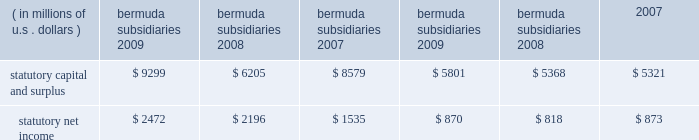N o t e s t o t h e c o n s o l i d a t e d f i n a n c i a l s t a t e m e n t s ( continued ) ace limited and subsidiaries 20 .
Statutory financial information the company 2019s insurance and reinsurance subsidiaries are subject to insurance laws and regulations in the jurisdictions in which they operate .
These regulations include restrictions that limit the amount of dividends or other distributions , such as loans or cash advances , available to shareholders without prior approval of the insurance regulatory authorities .
There are no statutory restrictions on the payment of dividends from retained earnings by any of the bermuda subsidiaries as the minimum statutory capital and surplus requirements are satisfied by the share capital and additional paid-in capital of each of the bermuda subsidiaries .
The company 2019s u.s .
Subsidiaries file financial statements prepared in accordance with statutory accounting practices prescribed or permitted by insurance regulators .
Statutory accounting differs from gaap in the reporting of certain reinsurance contracts , investments , subsidiaries , acquis- ition expenses , fixed assets , deferred income taxes , and certain other items .
The statutory capital and surplus of the u.s .
Subsidiaries met regulatory requirements for 2009 , 2008 , and 2007 .
The amount of dividends available to be paid in 2010 , without prior approval from the state insurance departments , totals $ 733 million .
The combined statutory capital and surplus and statutory net income of the bermuda and u.s .
Subsidiaries as at and for the years ended december 31 , 2009 , 2008 , and 2007 , are as follows: .
As permitted by the restructuring discussed previously in note 7 , certain of the company 2019s u.s .
Subsidiaries discount certain a&e liabilities , which increased statutory capital and surplus by approximately $ 215 million , $ 211 million , and $ 140 million at december 31 , 2009 , 2008 , and 2007 , respectively .
The company 2019s international subsidiaries prepare statutory financial statements based on local laws and regulations .
Some jurisdictions impose complex regulatory requirements on insurance companies while other jurisdictions impose fewer requirements .
In some countries , the company must obtain licenses issued by governmental authorities to conduct local insurance business .
These licenses may be subject to reserves and minimum capital and solvency tests .
Jurisdictions may impose fines , censure , and/or criminal sanctions for violation of regulatory requirements .
21 .
Information provided in connection with outstanding debt of subsidiaries the following tables present condensed consolidating financial information at december 31 , 2009 , and december 31 , 2008 , and for the years ended december 31 , 2009 , 2008 , and 2007 , for ace limited ( the parent guarantor ) and its 201csubsidiary issuer 201d , ace ina holdings , inc .
The subsidiary issuer is an indirect 100 percent-owned subsidiary of the parent guarantor .
Investments in subsidiaries are accounted for by the parent guarantor under the equity method for purposes of the supplemental consolidating presentation .
Earnings of subsidiaries are reflected in the parent guarantor 2019s investment accounts and earnings .
The parent guarantor fully and unconditionally guarantees certain of the debt of the subsidiary issuer. .
In 2009 what was the ratio of the statutory capital and surplus statutory net income? 
Computations: (9299 / 2472)
Answer: 3.76173. 